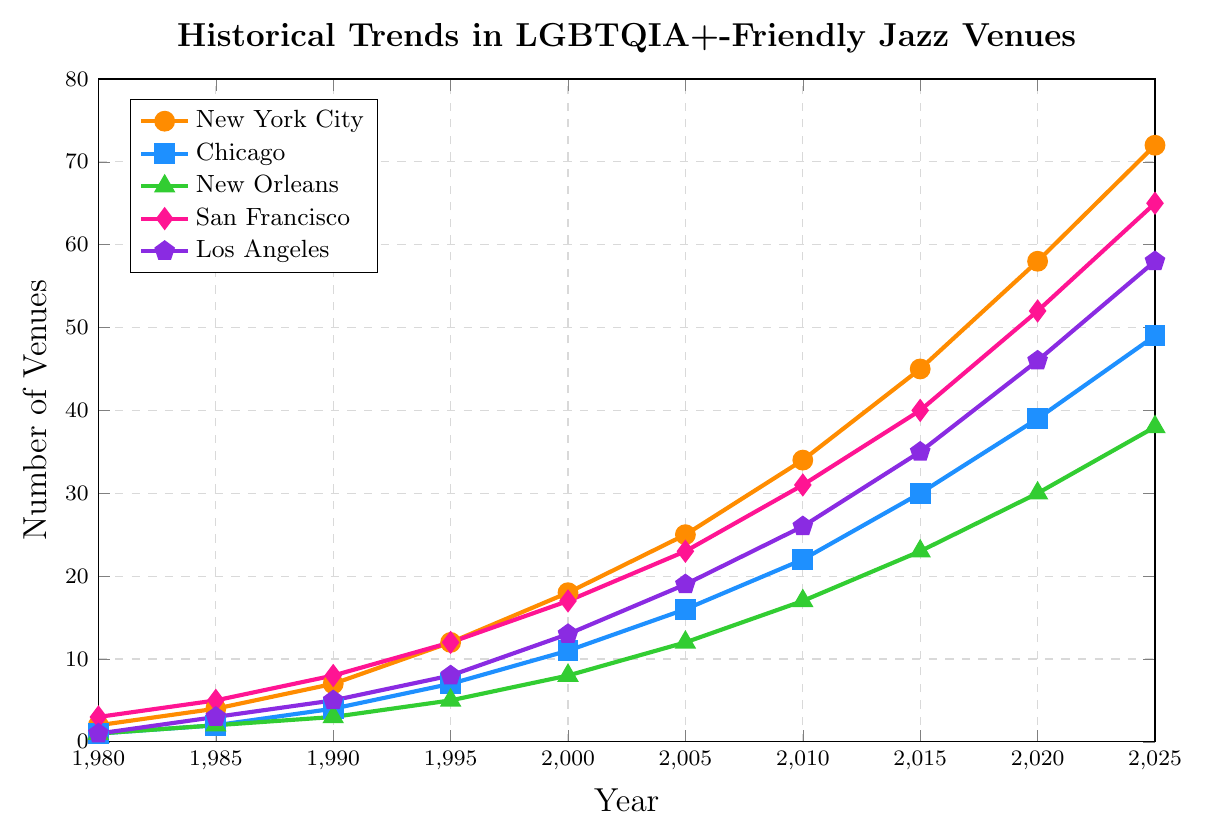what year did New York City have approximately double the number of LGBTQIA+-friendly jazz venues compared to Chicago? In 1995, New York City had 12 venues and Chicago had 7 venues. Doubling Chicago's number gives 14, which is close to New York City's value in 2000 when it had 18 venues while Chicago had 11 venues.
Answer: 2000 In 2025, how many more LGBTQIA+-friendly jazz venues does San Francisco have compared to New Orleans? In 2025, San Francisco has 65 venues and New Orleans has 38 venues. The difference is 65 - 38.
Answer: 27 Which city showed the greatest increase in the number of LGBTQIA+-friendly jazz venues from 1980 to 2025? To find the greatest increase, subtract the 1980 values from the 2025 values for each city: 
- New York City: 72 - 2 = 70
- Chicago: 49 - 1 = 48
- New Orleans: 38 - 1 = 37
- San Francisco: 65 - 3 = 62
- Los Angeles: 58 - 1 = 57
New York City has the highest increase.
Answer: New York City In what year did San Francisco's number of LGBTQIA+-friendly venues first surpass 50? The data shows San Francisco surpasses 50 in 2020 with 52 venues.
Answer: 2020 What is the average number of LGBTQIA+-friendly jazz venues across all cities in 2010? Sum the number of venues for all cities in 2010 and divide by the number of cities: 
34 (NYC) + 22 (Chicago) + 17 (New Orleans) + 31 (San Francisco) + 26 (LA) = 130. Divide by 5 to get the average: 130/5.
Answer: 26 Which city had the least number of LGBTQIA+-friendly jazz venues in 1980 and how many? Based on the data, in 1980, Chicago and New Orleans each had 1 venue, which is the least.
Answer: Chicago and New Orleans; 1 When did Los Angeles start lagging behind New York City by more than 10 venues? The gap between New York City and Los Angeles exceeded 10 venues in 2005 when New York City had 25 venues and Los Angeles had 19.
Answer: 2005 